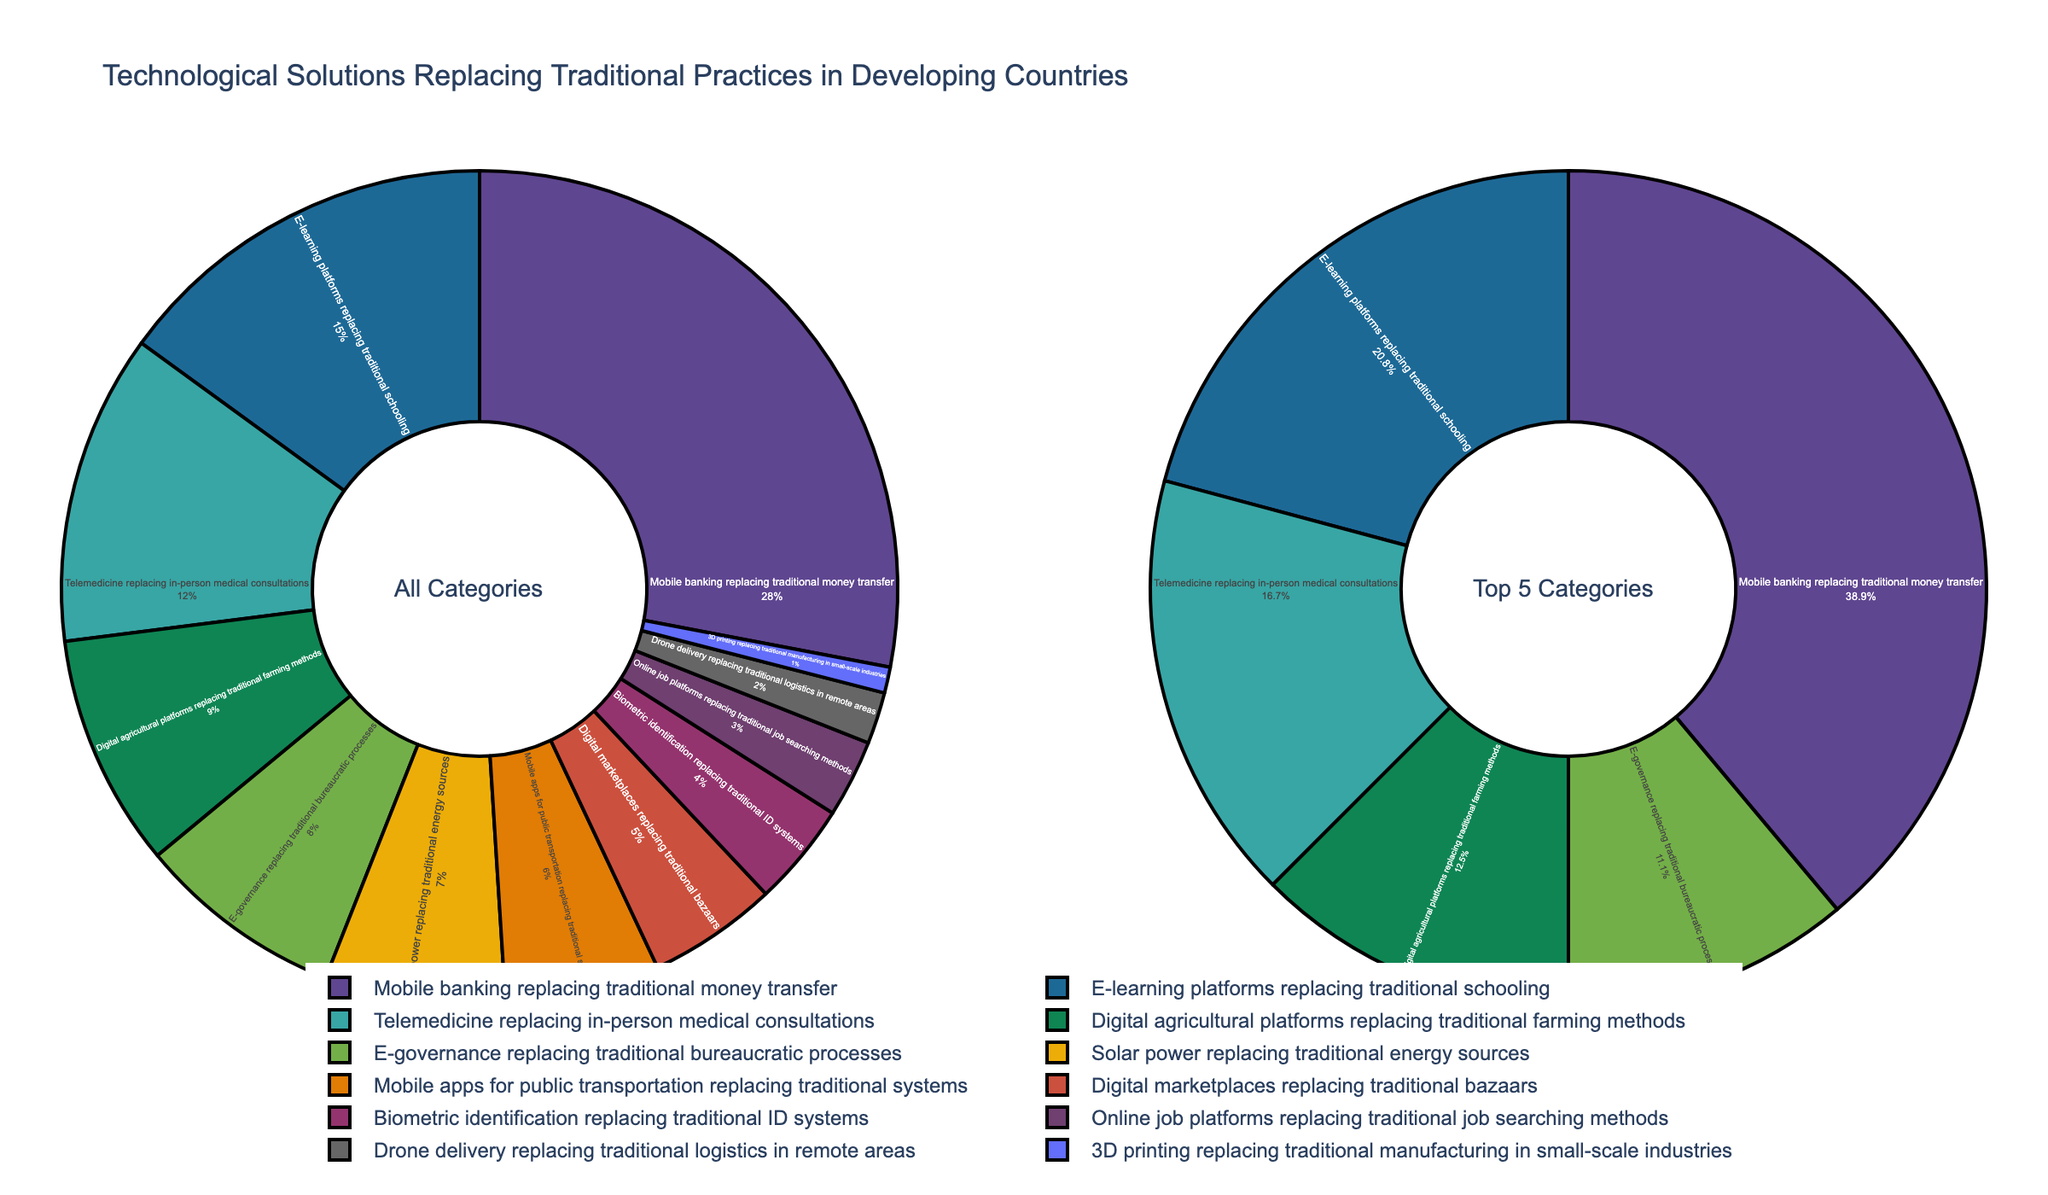What technological solution has the highest percentage of replacing traditional practices? The category with the highest percentage in the pie chart is "Mobile banking replacing traditional money transfer".
Answer: Mobile banking replacing traditional money transfer What percentage of traditional practices are replaced by E-learning platforms? The specific slice in the pie chart representing "E-learning platforms replacing traditional schooling" shows a percentage value.
Answer: 15% How does the percentage of Telemedicine compare to Digital agricultural platforms? Look at the pie chart and compare the percentage values for "Telemedicine replacing in-person medical consultations" and "Digital agricultural platforms replacing traditional farming methods". Telemedicine has 12%, whereas Digital agricultural platforms have 9%.
Answer: Telemedicine is higher What is the combined percentage of E-governance and Solar power replacing traditional practices? Sum the values of the two slices representing "E-governance replacing traditional bureaucratic processes" (8%) and "Solar power replacing traditional energy sources" (7%). 8% + 7% = 15%.
Answer: 15% Which has a lower percentage, Drone delivery or 3D printing? By examining the pie chart, it is seen that the slice for "Drone delivery replacing traditional logistics in remote areas" is 2% and the slice for "3D printing replacing traditional manufacturing in small-scale industries" is 1%.
Answer: 3D printing What are the top five technological solutions replacing traditional practices in terms of percentage? The right side of the pie chart labeled "Top 5 Categories" lists the categories with the highest percentages. These are "Mobile banking replacing traditional money transfer" (28%), "E-learning platforms replacing traditional schooling" (15%), "Telemedicine replacing in-person medical consultations" (12%), "Digital agricultural platforms replacing traditional farming methods" (9%), "E-governance replacing traditional bureaucratic processes" (8%).
Answer: Mobile banking, E-learning platforms, Telemedicine, Digital agricultural platforms, E-governance Between Digital marketplaces and Online job platforms, which one replaces traditional practices more and by how much? The percentages for "Digital marketplaces replacing traditional bazaars" and "Online job platforms replacing traditional job searching methods" are 5% and 3% respectively. The difference is 5% - 3% = 2%.
Answer: Digital marketplaces by 2% What is the total percentage of practices replaced by technological solutions that are less than 10%? Sum the percentages of all categories with values less than 10%. These are: Digital agricultural platforms (9%), E-governance (8%), Solar power (7%), Public transportation (6%), Digital marketplaces (5%), Biometric ID (4%), Online job platforms (3%), Drone delivery (2%), 3D printing (1%). 9% + 8% + 7% + 6% + 5% + 4% + 3% + 2% + 1% = 45%.
Answer: 45% What is the difference in percentage between the top category and the lowest category? The top category "Mobile banking replacing traditional money transfer" has a percentage of 28%, and the lowest category "3D printing replacing traditional manufacturing in small-scale industries" has 1%. The difference is 28% - 1%.
Answer: 27% Which categories replace traditional practices by 10% or more? Identify categories with percentages 10% or higher from the pie chart. These are "Mobile banking replacing traditional money transfer" (28%), "E-learning platforms replacing traditional schooling" (15%), and "Telemedicine replacing in-person medical consultations" (12%).
Answer: Mobile banking, E-learning platforms, Telemedicine 